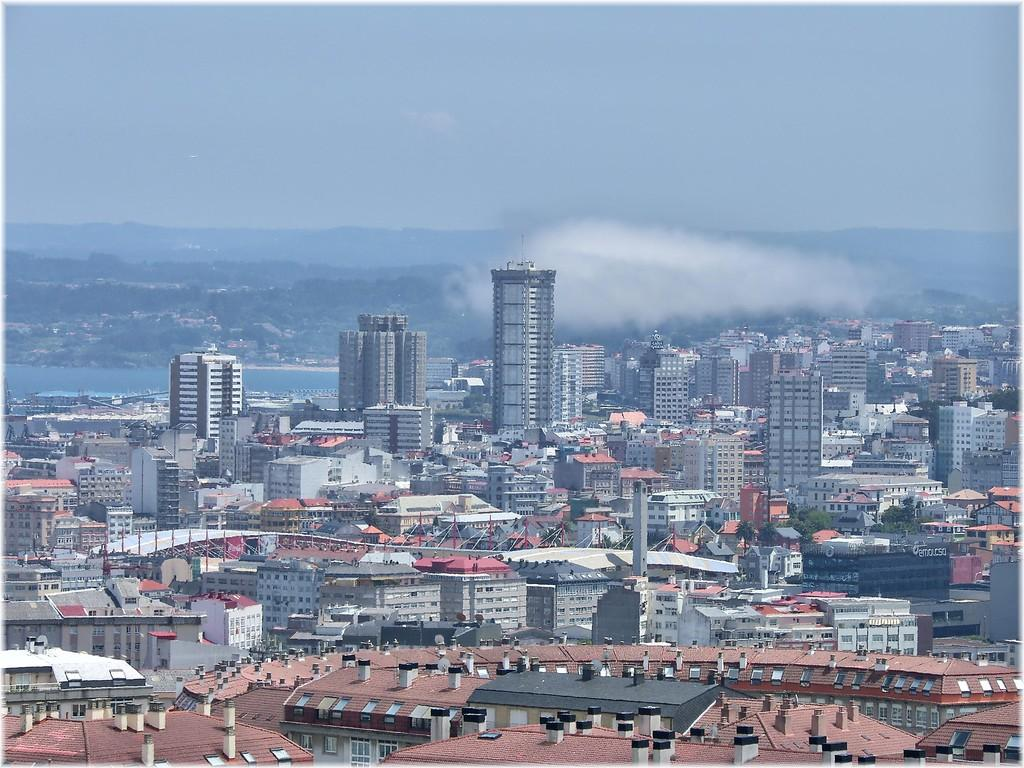What type of structures are present in the image? There are buildings in the image. How are the buildings arranged in the image? The buildings are arranged from left to right. What natural element can be seen in the image? There is water visible in the image. What type of vegetation is in the background of the image? There are trees in the background of the image. What is visible at the top of the image? The sky is visible at the top of the image. Can you tell me how many visitors are standing near the boy in the image? There is no boy or visitors present in the image; it features buildings, water, trees, and the sky. 